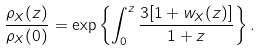Convert formula to latex. <formula><loc_0><loc_0><loc_500><loc_500>\frac { \rho _ { X } ( z ) } { \rho _ { X } ( 0 ) } = \exp \left \{ \int _ { 0 } ^ { z } \frac { 3 [ 1 + w _ { X } ( z ) ] } { 1 + z } \right \} .</formula> 